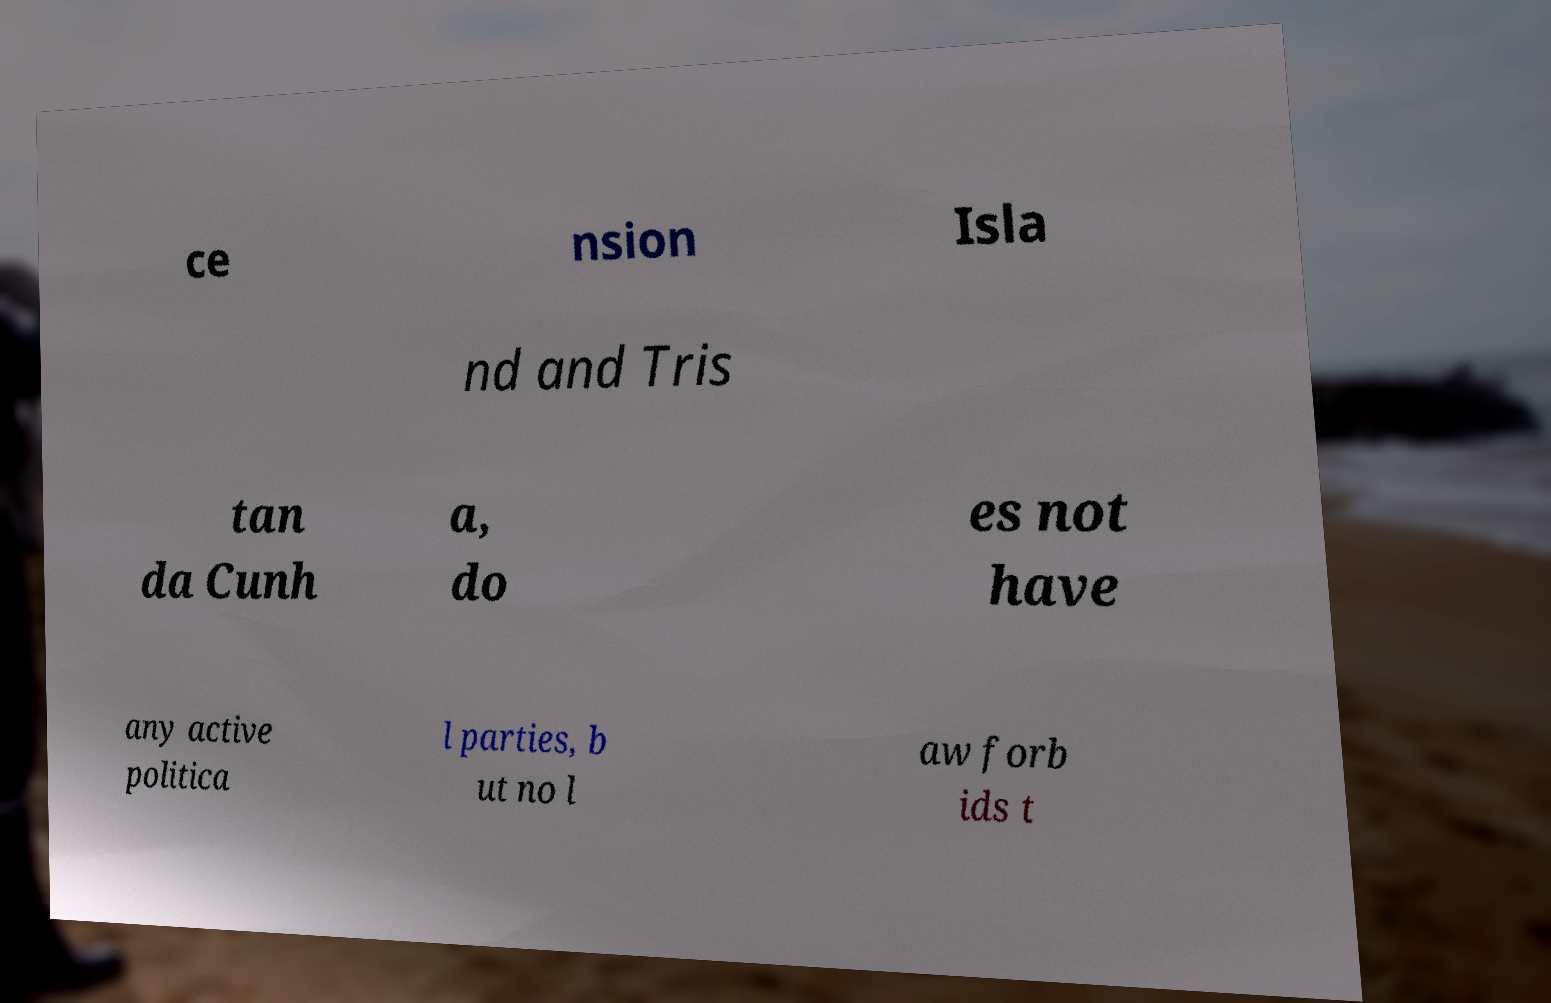Can you accurately transcribe the text from the provided image for me? ce nsion Isla nd and Tris tan da Cunh a, do es not have any active politica l parties, b ut no l aw forb ids t 